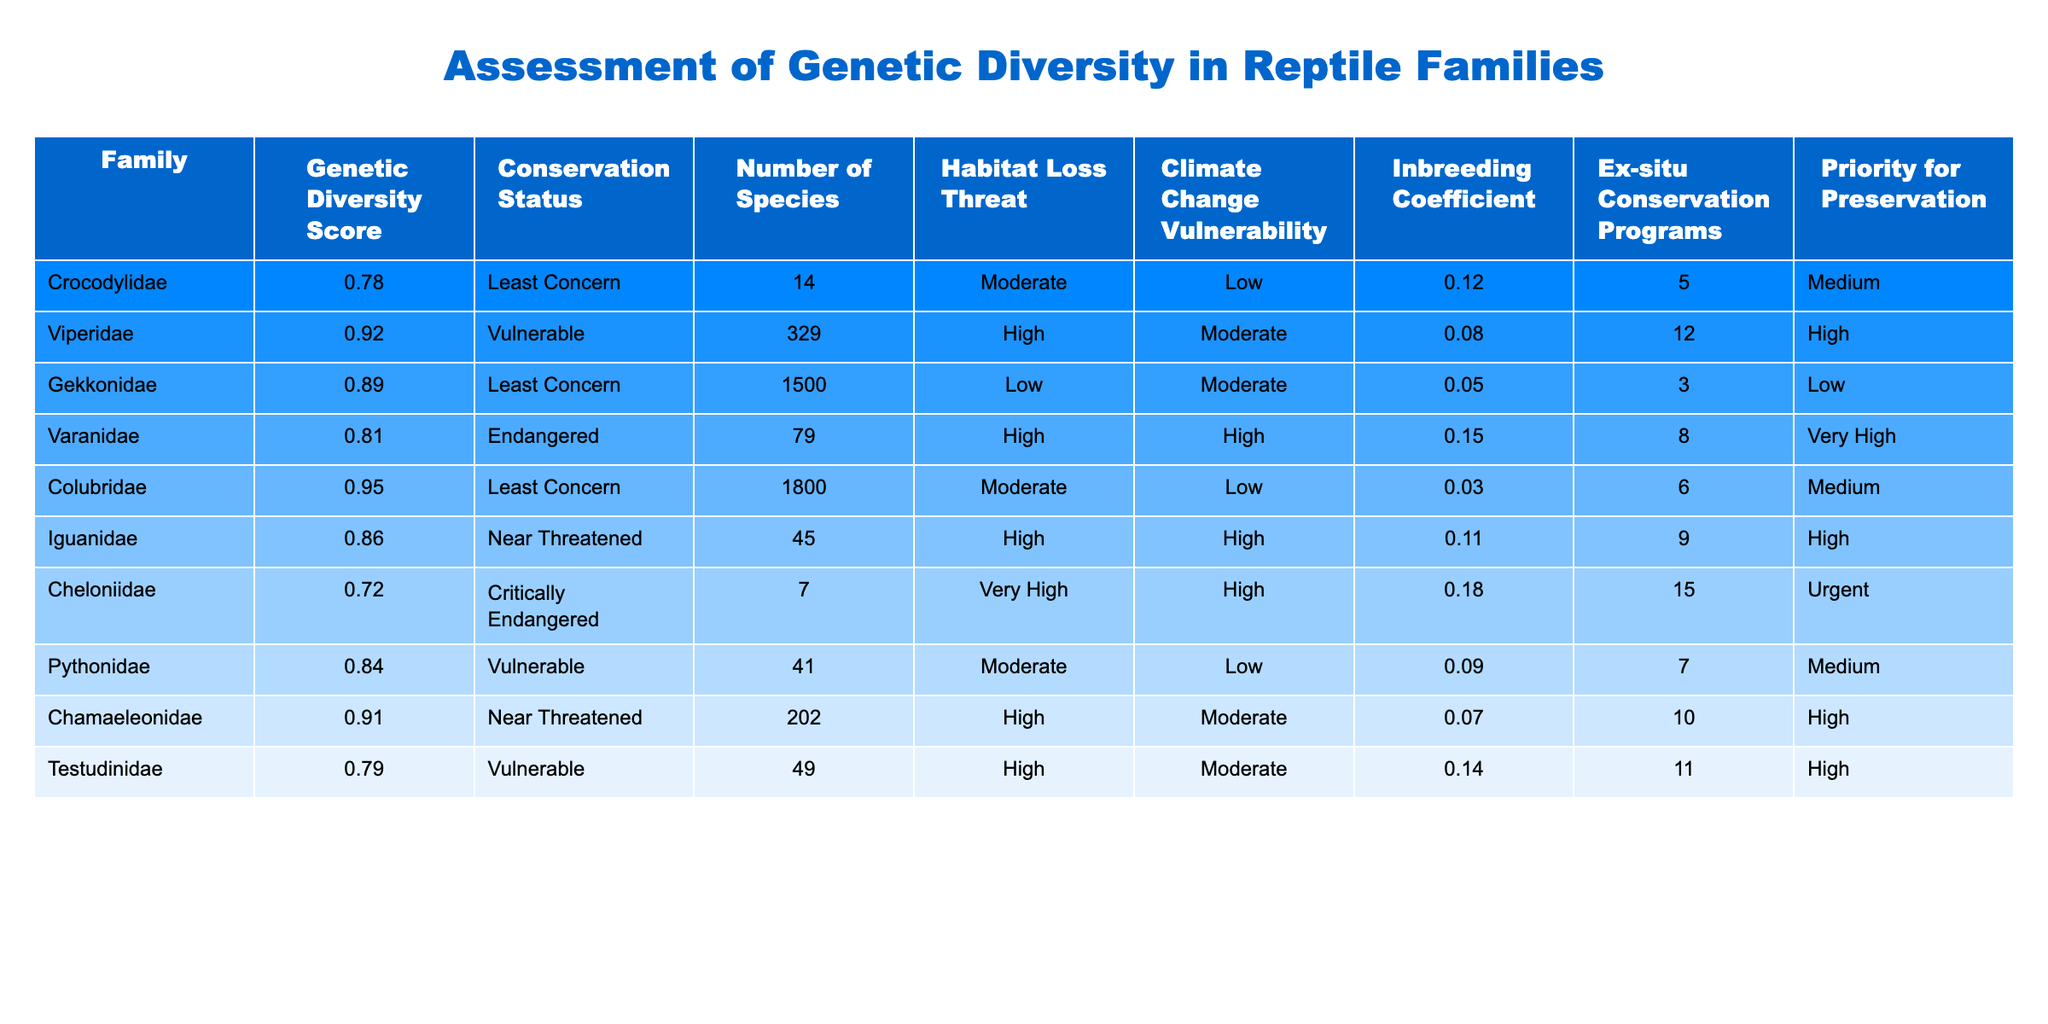What is the genetic diversity score of the Cheloniidae family? The genetic diversity score for Cheloniidae can be found in the table under the "Genetic Diversity Score" column corresponding to the Cheloniidae row, which states it is 0.72.
Answer: 0.72 How many species are in the Viperidae family? Looking at the "Number of Species" column for the Viperidae row, it shows that there are 329 species in this family.
Answer: 329 Which reptile family has the highest inbreeding coefficient? To find the highest inbreeding coefficient, I will compare the values in the "Inbreeding Coefficient" column. The values are 0.12, 0.08, 0.05, 0.15, 0.03, 0.11, 0.18, 0.09, 0.07, and 0.14. The highest value is 0.18 for the Cheloniidae family.
Answer: Cheloniidae Is the Varanidae family considered critically endangered? By checking the "Conservation Status" for Varanidae, it states "Endangered," which is not the same as "Critically Endangered," so the answer is no.
Answer: No What is the average genetic diversity score for the families with a conservation status of "Vulnerable"? The Viperidae, Pythonidae, and Testudinidae families are marked as "Vulnerable," with genetic diversity scores of 0.92, 0.84, and 0.79 respectively. To find the average, I sum these scores (0.92 + 0.84 + 0.79 = 2.55) and divide by 3, resulting in an average of approximately 0.85.
Answer: 0.85 Which family has the highest priority for preservation and what is its conservation status? From the "Priority for Preservation" column, "Urgent" status indicates the highest priority. The Cheloniidae family has that status, and its conservation status is "Critically Endangered." Thus, both values are assessed from the table appropriately.
Answer: Cheloniidae; Critically Endangered Is there an ex-situ conservation program for the Crocodylidae family? The table lists an "Ex-situ Conservation Programs" value of 5 for the Crocodylidae family. Since this number is greater than zero, it indicates that there is indeed a program in place.
Answer: Yes What is the difference in the number of species between the Gekkonidae and the Viperidae families? The Gekkonidae family has 1500 species, while the Viperidae family has 329 species. To find the difference, I subtract these values (1500 - 329 = 1171), showing there are 1171 more species in Gekkonidae.
Answer: 1171 Which family is more vulnerable to climate change, Varanidae or Iguanidae? Checking the "Climate Change Vulnerability" column, Varanidae is marked as "High" and Iguanidae is also "High". Therefore, they are equally vulnerable to climate change based on the information in the table.
Answer: They are equally vulnerable 